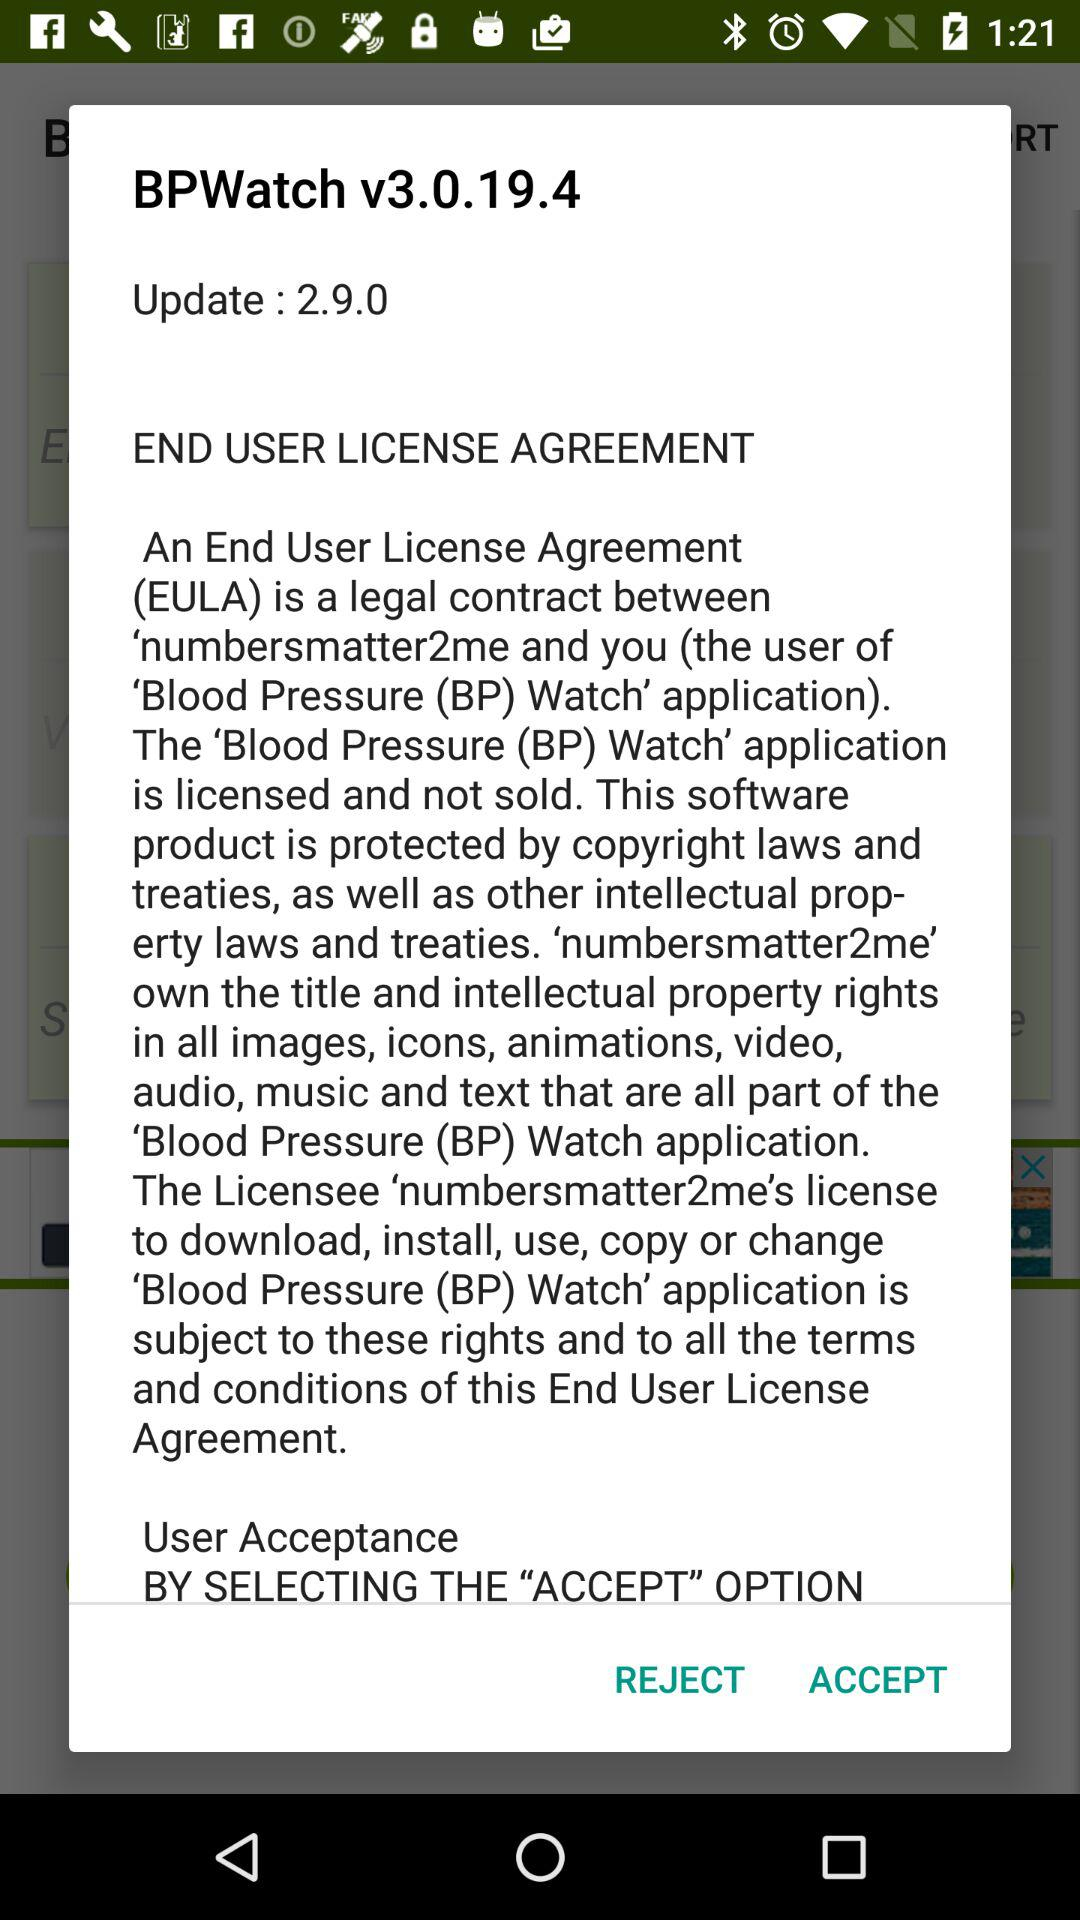Which version of "BPWatch" is used? The used version is v3.0.19.4. 